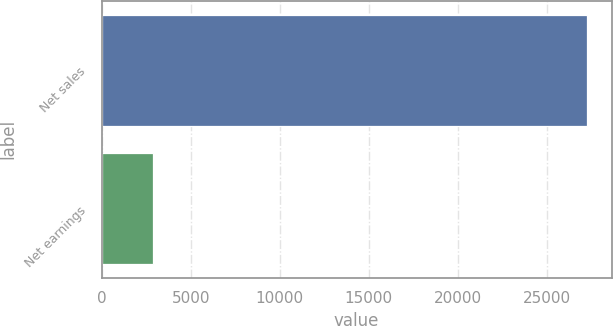Convert chart to OTSL. <chart><loc_0><loc_0><loc_500><loc_500><bar_chart><fcel>Net sales<fcel>Net earnings<nl><fcel>27254<fcel>2915<nl></chart> 